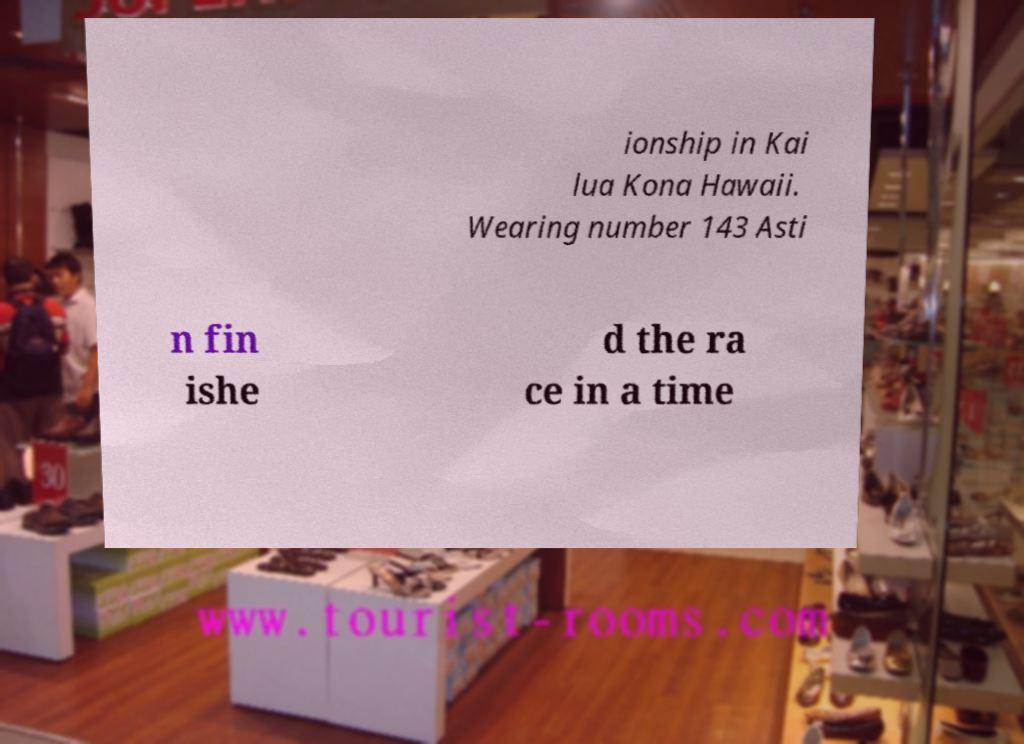I need the written content from this picture converted into text. Can you do that? ionship in Kai lua Kona Hawaii. Wearing number 143 Asti n fin ishe d the ra ce in a time 